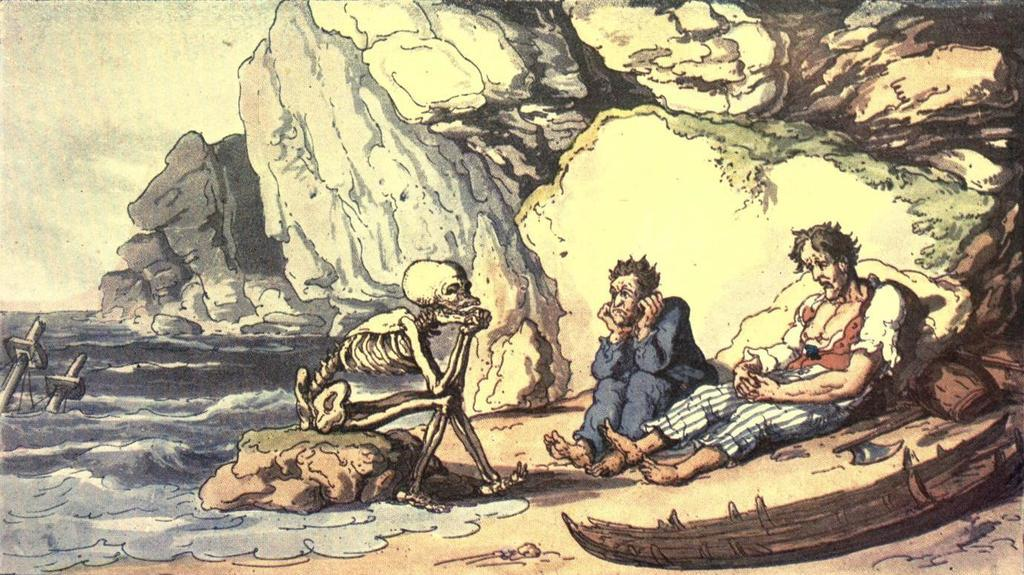What is the main subject of the painting? The painting depicts a hill. What can be seen in the sky in the painting? The painting includes a sky. Is there any water visible in the painting? Yes, there is water in the painting. What type of vehicle is present in the painting? A boat is present in the painting. Are there any people depicted in the painting? Yes, people are depicted in the painting. What type of weapon can be seen in the painting? Weapons are visible in the painting. Is there any skeletal figure included in the painting? Yes, a skeleton is included in the painting. What type of natural formation is present in the painting? Rocks are present in the painting. What type of tool is depicted in the painting? An axe is depicted in the painting. Can you describe the variety of objects present in the painting? There are various objects in the painting. How many bushes are present in the painting? There is no mention of bushes in the provided facts, so we cannot determine the number of bushes in the painting. 